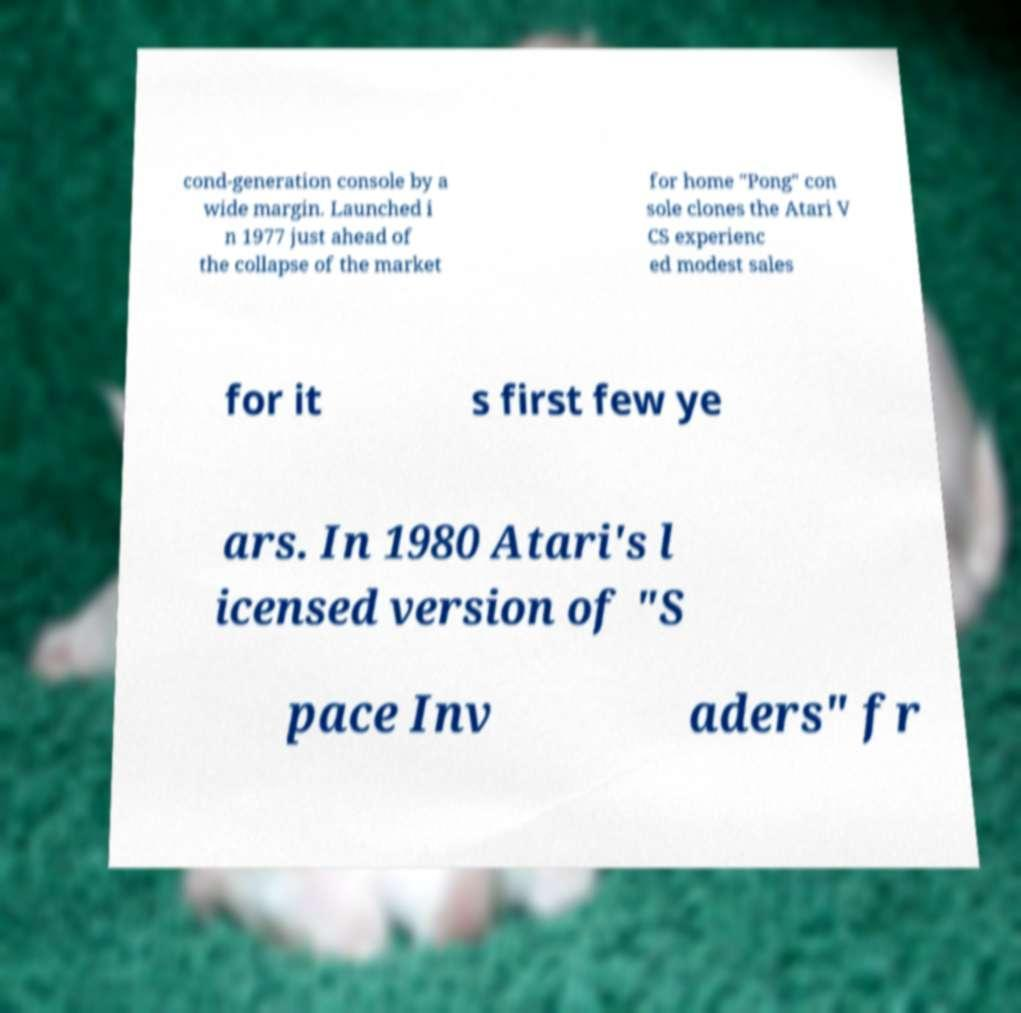Please read and relay the text visible in this image. What does it say? cond-generation console by a wide margin. Launched i n 1977 just ahead of the collapse of the market for home "Pong" con sole clones the Atari V CS experienc ed modest sales for it s first few ye ars. In 1980 Atari's l icensed version of "S pace Inv aders" fr 